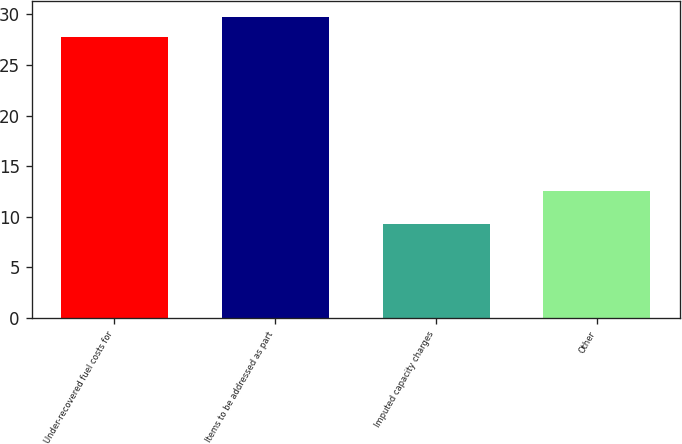<chart> <loc_0><loc_0><loc_500><loc_500><bar_chart><fcel>Under-recovered fuel costs for<fcel>Items to be addressed as part<fcel>Imputed capacity charges<fcel>Other<nl><fcel>27.8<fcel>29.77<fcel>9.3<fcel>12.5<nl></chart> 